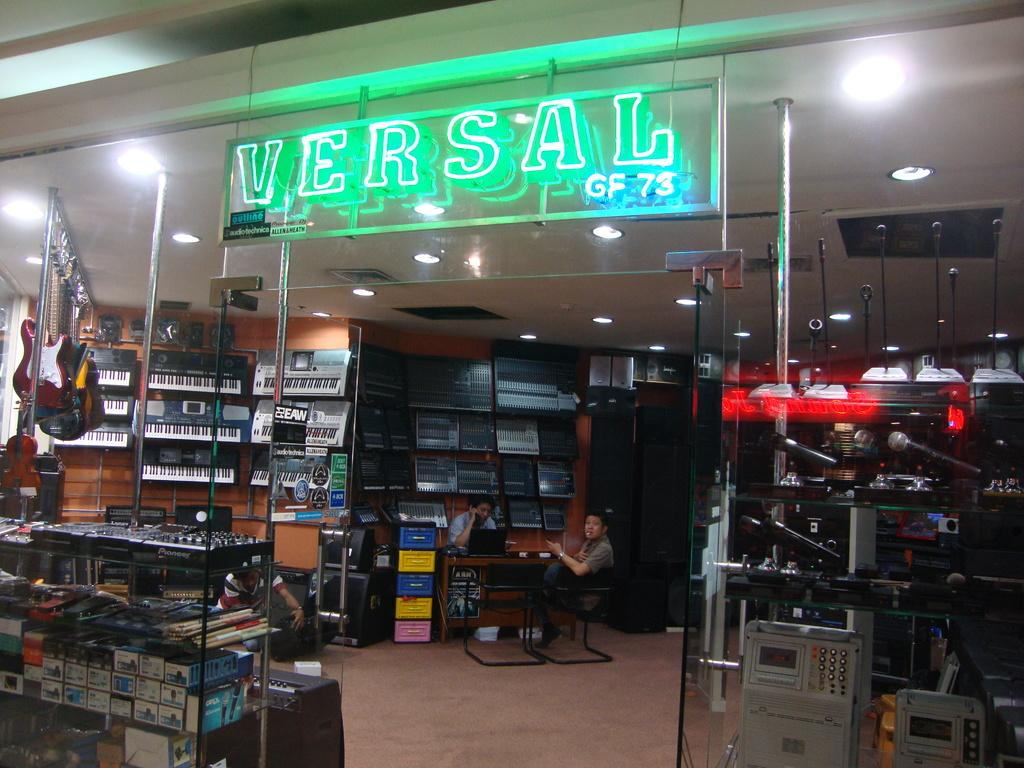<image>
Share a concise interpretation of the image provided. A music store called Versal displaying various musical instruments including keyboards. 